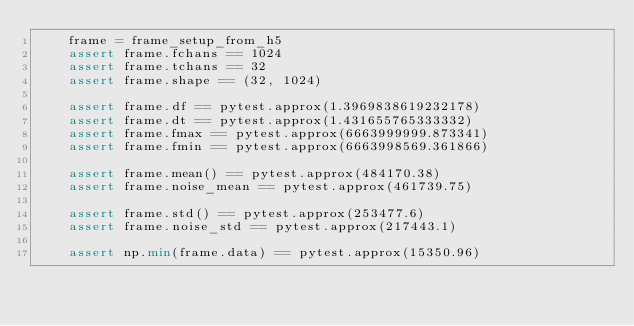Convert code to text. <code><loc_0><loc_0><loc_500><loc_500><_Python_>    frame = frame_setup_from_h5
    assert frame.fchans == 1024
    assert frame.tchans == 32
    assert frame.shape == (32, 1024)

    assert frame.df == pytest.approx(1.3969838619232178)
    assert frame.dt == pytest.approx(1.431655765333332)
    assert frame.fmax == pytest.approx(6663999999.873341)
    assert frame.fmin == pytest.approx(6663998569.361866)

    assert frame.mean() == pytest.approx(484170.38)
    assert frame.noise_mean == pytest.approx(461739.75)

    assert frame.std() == pytest.approx(253477.6)
    assert frame.noise_std == pytest.approx(217443.1)

    assert np.min(frame.data) == pytest.approx(15350.96)
</code> 